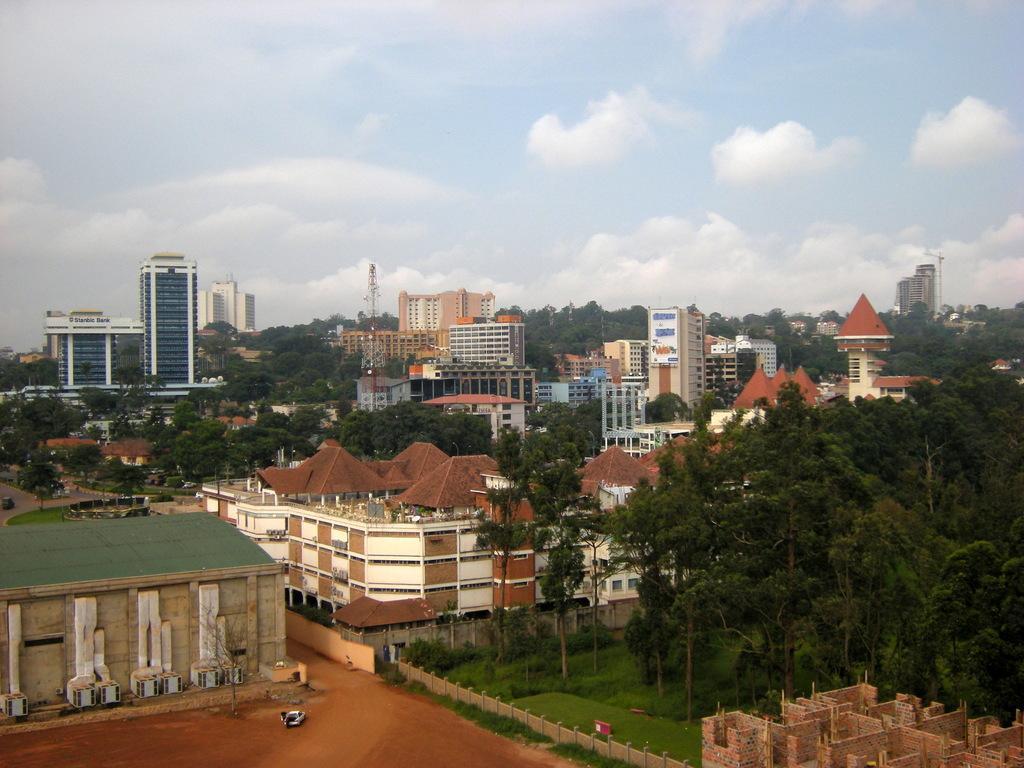Can you describe this image briefly? As we can see in the image there are buildings, grass, trees, sky and clouds. 